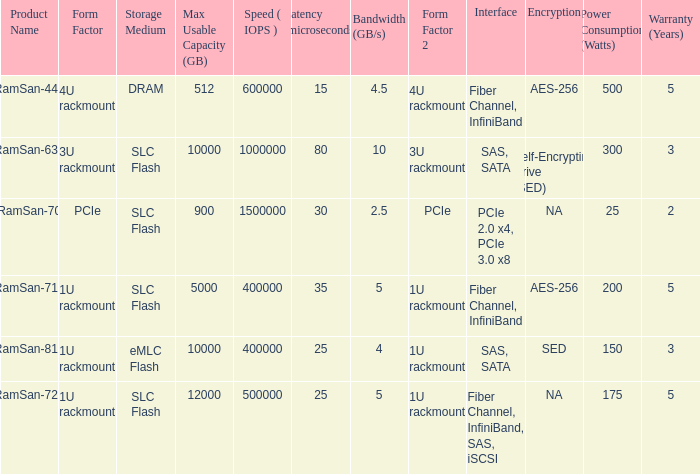What is the shape distortion for the range frequency of 10? 3U rackmount. Parse the table in full. {'header': ['Product Name', 'Form Factor', 'Storage Medium', 'Max Usable Capacity (GB)', 'Speed ( IOPS )', 'Latency (microseconds)', 'Bandwidth (GB/s)', 'Form Factor 2', 'Interface', 'Encryption', 'Power Consumption (Watts)', 'Warranty (Years)'], 'rows': [['RamSan-440', '4U rackmount', 'DRAM', '512', '600000', '15', '4.5', '4U rackmount', 'Fiber Channel, InfiniBand', 'AES-256', '500', '5'], ['RamSan-630', '3U rackmount', 'SLC Flash', '10000', '1000000', '80', '10', '3U rackmount', 'SAS, SATA', 'Self-Encrypting Drive (SED)', '300', '3'], ['RamSan-70', 'PCIe', 'SLC Flash', '900', '1500000', '30', '2.5', 'PCIe', 'PCIe 2.0 x4, PCIe 3.0 x8', 'NA', '25', '2'], ['RamSan-710', '1U rackmount', 'SLC Flash', '5000', '400000', '35', '5', '1U rackmount', 'Fiber Channel, InfiniBand', 'AES-256', '200', '5'], ['RamSan-810', '1U rackmount', 'eMLC Flash', '10000', '400000', '25', '4', '1U rackmount', 'SAS, SATA', 'SED', '150', '3'], ['RamSan-720', '1U rackmount', 'SLC Flash', '12000', '500000', '25', '5', '1U rackmount', 'Fiber Channel, InfiniBand, SAS, iSCSI', 'NA', '175', '5']]} 